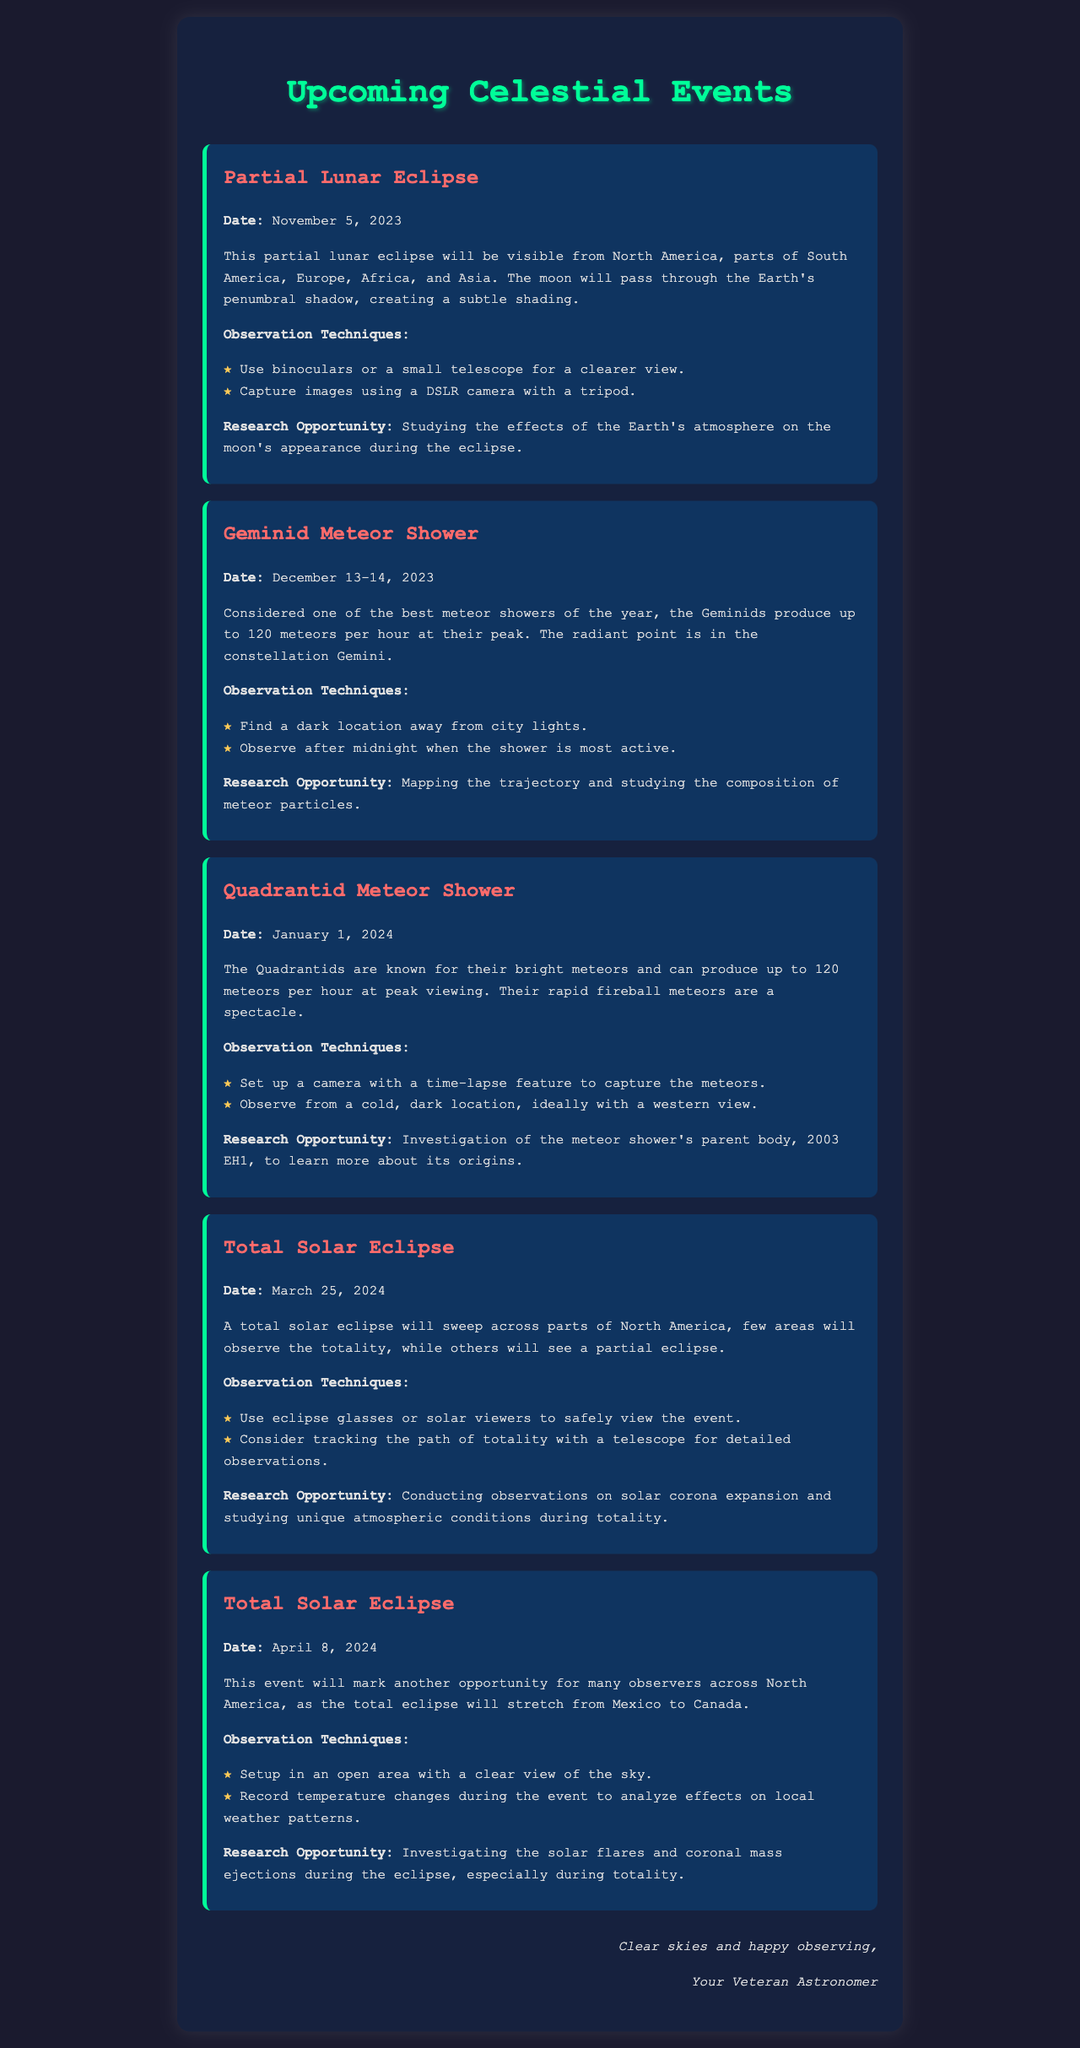What is the date of the Partial Lunar Eclipse? The date of the Partial Lunar Eclipse is stated in the document.
Answer: November 5, 2023 How many meteors per hour can be seen during the peak of the Geminid Meteor Shower? The document specifies the peak rate of meteors during the Geminid Meteor Shower.
Answer: 120 meteors per hour What observation technique is suggested for the Total Solar Eclipse on April 8, 2024? The document lists specific observation techniques for each event, including the April 8 eclipse.
Answer: Setup in an open area with a clear view of the sky What is the research opportunity during the Quadrantid Meteor Shower? The document describes potential research opportunities associated with the Quadrantid Meteor Shower.
Answer: Investigation of the meteor shower's parent body, 2003 EH1 What celestial event occurs on January 1, 2024? The document clearly mentions the celestial event occurring on that date.
Answer: Quadrantid Meteor Shower Which observation technique is recommended for the Geminid Meteor Shower? The document provides suggestions on where and how to observe the Geminid Meteor Shower.
Answer: Find a dark location away from city lights What is the main focus of research during the total solar eclipse? The document highlights specific aspects to study during total solar eclipses.
Answer: Investigating the solar flares and coronal mass ejections during the eclipse How many total solar eclipses are mentioned in the document? The document lists multiple occurrences of total solar eclipses and their respective dates.
Answer: 2 total solar eclipses 